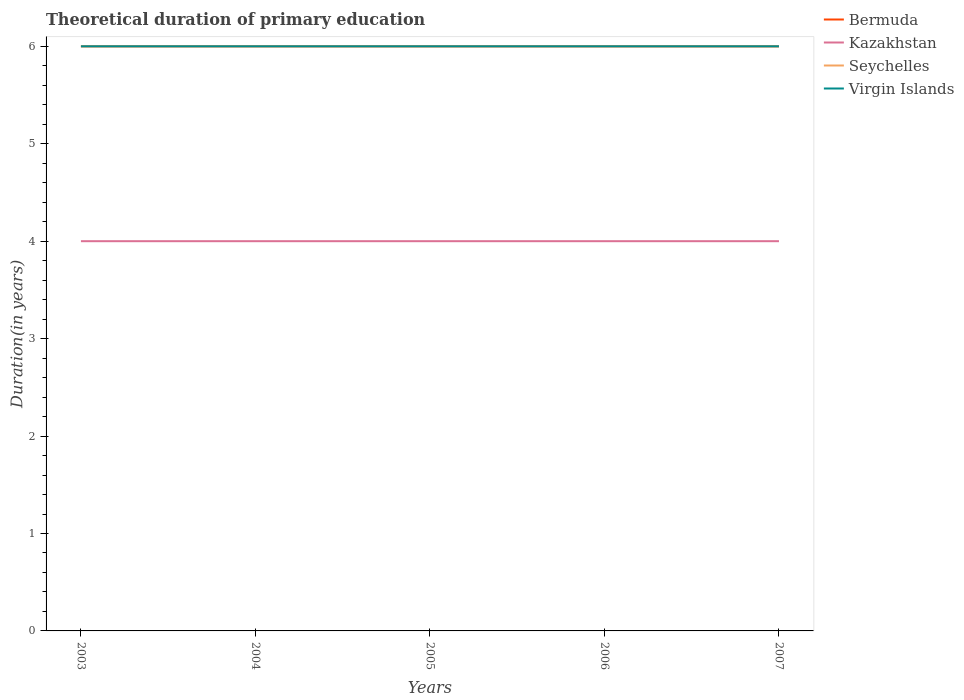What is the total total theoretical duration of primary education in Bermuda in the graph?
Offer a very short reply. 0. Is the total theoretical duration of primary education in Seychelles strictly greater than the total theoretical duration of primary education in Bermuda over the years?
Make the answer very short. No. How many lines are there?
Provide a short and direct response. 4. How many years are there in the graph?
Ensure brevity in your answer.  5. What is the difference between two consecutive major ticks on the Y-axis?
Your answer should be very brief. 1. Does the graph contain grids?
Offer a very short reply. No. How many legend labels are there?
Your answer should be compact. 4. What is the title of the graph?
Keep it short and to the point. Theoretical duration of primary education. Does "Namibia" appear as one of the legend labels in the graph?
Make the answer very short. No. What is the label or title of the X-axis?
Your answer should be very brief. Years. What is the label or title of the Y-axis?
Provide a short and direct response. Duration(in years). What is the Duration(in years) of Seychelles in 2003?
Your answer should be very brief. 6. What is the Duration(in years) in Virgin Islands in 2003?
Offer a terse response. 6. What is the Duration(in years) in Bermuda in 2004?
Your answer should be compact. 6. What is the Duration(in years) in Kazakhstan in 2004?
Ensure brevity in your answer.  4. What is the Duration(in years) in Kazakhstan in 2005?
Ensure brevity in your answer.  4. What is the Duration(in years) of Seychelles in 2006?
Offer a very short reply. 6. What is the Duration(in years) in Kazakhstan in 2007?
Keep it short and to the point. 4. What is the Duration(in years) in Seychelles in 2007?
Your answer should be compact. 6. What is the Duration(in years) of Virgin Islands in 2007?
Offer a terse response. 6. Across all years, what is the maximum Duration(in years) in Kazakhstan?
Offer a terse response. 4. Across all years, what is the maximum Duration(in years) in Seychelles?
Give a very brief answer. 6. Across all years, what is the minimum Duration(in years) of Bermuda?
Keep it short and to the point. 6. What is the total Duration(in years) of Kazakhstan in the graph?
Keep it short and to the point. 20. What is the total Duration(in years) in Virgin Islands in the graph?
Your answer should be compact. 30. What is the difference between the Duration(in years) of Bermuda in 2003 and that in 2004?
Your answer should be compact. 0. What is the difference between the Duration(in years) of Kazakhstan in 2003 and that in 2004?
Provide a succinct answer. 0. What is the difference between the Duration(in years) in Virgin Islands in 2003 and that in 2004?
Provide a succinct answer. 0. What is the difference between the Duration(in years) of Kazakhstan in 2003 and that in 2005?
Your answer should be compact. 0. What is the difference between the Duration(in years) of Seychelles in 2003 and that in 2005?
Ensure brevity in your answer.  0. What is the difference between the Duration(in years) of Virgin Islands in 2003 and that in 2005?
Your answer should be very brief. 0. What is the difference between the Duration(in years) of Seychelles in 2003 and that in 2006?
Ensure brevity in your answer.  0. What is the difference between the Duration(in years) in Bermuda in 2003 and that in 2007?
Provide a short and direct response. 0. What is the difference between the Duration(in years) in Bermuda in 2004 and that in 2005?
Keep it short and to the point. 0. What is the difference between the Duration(in years) in Kazakhstan in 2004 and that in 2006?
Ensure brevity in your answer.  0. What is the difference between the Duration(in years) of Seychelles in 2004 and that in 2006?
Provide a succinct answer. 0. What is the difference between the Duration(in years) in Virgin Islands in 2004 and that in 2007?
Make the answer very short. 0. What is the difference between the Duration(in years) in Kazakhstan in 2005 and that in 2006?
Give a very brief answer. 0. What is the difference between the Duration(in years) of Virgin Islands in 2005 and that in 2006?
Your answer should be very brief. 0. What is the difference between the Duration(in years) in Virgin Islands in 2006 and that in 2007?
Offer a very short reply. 0. What is the difference between the Duration(in years) of Bermuda in 2003 and the Duration(in years) of Seychelles in 2004?
Your answer should be very brief. 0. What is the difference between the Duration(in years) of Bermuda in 2003 and the Duration(in years) of Virgin Islands in 2004?
Ensure brevity in your answer.  0. What is the difference between the Duration(in years) of Kazakhstan in 2003 and the Duration(in years) of Seychelles in 2004?
Your answer should be compact. -2. What is the difference between the Duration(in years) in Bermuda in 2003 and the Duration(in years) in Seychelles in 2005?
Provide a short and direct response. 0. What is the difference between the Duration(in years) in Bermuda in 2003 and the Duration(in years) in Kazakhstan in 2006?
Keep it short and to the point. 2. What is the difference between the Duration(in years) in Kazakhstan in 2003 and the Duration(in years) in Seychelles in 2006?
Offer a terse response. -2. What is the difference between the Duration(in years) in Kazakhstan in 2003 and the Duration(in years) in Virgin Islands in 2006?
Provide a succinct answer. -2. What is the difference between the Duration(in years) of Bermuda in 2003 and the Duration(in years) of Virgin Islands in 2007?
Your answer should be compact. 0. What is the difference between the Duration(in years) in Kazakhstan in 2003 and the Duration(in years) in Virgin Islands in 2007?
Provide a short and direct response. -2. What is the difference between the Duration(in years) in Bermuda in 2004 and the Duration(in years) in Virgin Islands in 2005?
Keep it short and to the point. 0. What is the difference between the Duration(in years) of Kazakhstan in 2004 and the Duration(in years) of Seychelles in 2005?
Your answer should be very brief. -2. What is the difference between the Duration(in years) of Kazakhstan in 2004 and the Duration(in years) of Virgin Islands in 2006?
Provide a succinct answer. -2. What is the difference between the Duration(in years) in Bermuda in 2004 and the Duration(in years) in Seychelles in 2007?
Provide a short and direct response. 0. What is the difference between the Duration(in years) in Bermuda in 2005 and the Duration(in years) in Kazakhstan in 2006?
Your response must be concise. 2. What is the difference between the Duration(in years) in Bermuda in 2005 and the Duration(in years) in Seychelles in 2006?
Make the answer very short. 0. What is the difference between the Duration(in years) in Bermuda in 2005 and the Duration(in years) in Virgin Islands in 2006?
Offer a very short reply. 0. What is the difference between the Duration(in years) of Kazakhstan in 2005 and the Duration(in years) of Seychelles in 2006?
Your response must be concise. -2. What is the difference between the Duration(in years) in Bermuda in 2005 and the Duration(in years) in Virgin Islands in 2007?
Make the answer very short. 0. What is the difference between the Duration(in years) in Bermuda in 2006 and the Duration(in years) in Seychelles in 2007?
Your answer should be compact. 0. What is the difference between the Duration(in years) in Kazakhstan in 2006 and the Duration(in years) in Seychelles in 2007?
Make the answer very short. -2. What is the difference between the Duration(in years) in Seychelles in 2006 and the Duration(in years) in Virgin Islands in 2007?
Provide a succinct answer. 0. What is the average Duration(in years) in Kazakhstan per year?
Offer a terse response. 4. What is the average Duration(in years) in Seychelles per year?
Provide a succinct answer. 6. In the year 2003, what is the difference between the Duration(in years) of Bermuda and Duration(in years) of Seychelles?
Your response must be concise. 0. In the year 2003, what is the difference between the Duration(in years) of Bermuda and Duration(in years) of Virgin Islands?
Offer a terse response. 0. In the year 2004, what is the difference between the Duration(in years) of Bermuda and Duration(in years) of Virgin Islands?
Offer a terse response. 0. In the year 2004, what is the difference between the Duration(in years) in Kazakhstan and Duration(in years) in Virgin Islands?
Ensure brevity in your answer.  -2. In the year 2004, what is the difference between the Duration(in years) of Seychelles and Duration(in years) of Virgin Islands?
Provide a succinct answer. 0. In the year 2005, what is the difference between the Duration(in years) in Kazakhstan and Duration(in years) in Seychelles?
Provide a short and direct response. -2. In the year 2005, what is the difference between the Duration(in years) in Kazakhstan and Duration(in years) in Virgin Islands?
Offer a terse response. -2. In the year 2006, what is the difference between the Duration(in years) in Bermuda and Duration(in years) in Kazakhstan?
Make the answer very short. 2. In the year 2006, what is the difference between the Duration(in years) in Bermuda and Duration(in years) in Seychelles?
Your answer should be very brief. 0. In the year 2006, what is the difference between the Duration(in years) of Kazakhstan and Duration(in years) of Seychelles?
Offer a very short reply. -2. In the year 2007, what is the difference between the Duration(in years) in Bermuda and Duration(in years) in Kazakhstan?
Make the answer very short. 2. In the year 2007, what is the difference between the Duration(in years) of Kazakhstan and Duration(in years) of Seychelles?
Your answer should be very brief. -2. In the year 2007, what is the difference between the Duration(in years) in Seychelles and Duration(in years) in Virgin Islands?
Make the answer very short. 0. What is the ratio of the Duration(in years) in Seychelles in 2003 to that in 2004?
Give a very brief answer. 1. What is the ratio of the Duration(in years) in Bermuda in 2003 to that in 2005?
Give a very brief answer. 1. What is the ratio of the Duration(in years) in Seychelles in 2003 to that in 2005?
Offer a very short reply. 1. What is the ratio of the Duration(in years) in Bermuda in 2003 to that in 2006?
Keep it short and to the point. 1. What is the ratio of the Duration(in years) in Kazakhstan in 2003 to that in 2006?
Offer a very short reply. 1. What is the ratio of the Duration(in years) in Virgin Islands in 2003 to that in 2006?
Give a very brief answer. 1. What is the ratio of the Duration(in years) in Kazakhstan in 2003 to that in 2007?
Your answer should be compact. 1. What is the ratio of the Duration(in years) of Seychelles in 2003 to that in 2007?
Your answer should be very brief. 1. What is the ratio of the Duration(in years) in Virgin Islands in 2003 to that in 2007?
Give a very brief answer. 1. What is the ratio of the Duration(in years) of Seychelles in 2004 to that in 2005?
Provide a succinct answer. 1. What is the ratio of the Duration(in years) of Virgin Islands in 2004 to that in 2005?
Keep it short and to the point. 1. What is the ratio of the Duration(in years) of Bermuda in 2004 to that in 2006?
Keep it short and to the point. 1. What is the ratio of the Duration(in years) in Kazakhstan in 2004 to that in 2006?
Offer a terse response. 1. What is the ratio of the Duration(in years) of Virgin Islands in 2004 to that in 2006?
Your answer should be compact. 1. What is the ratio of the Duration(in years) in Bermuda in 2004 to that in 2007?
Make the answer very short. 1. What is the ratio of the Duration(in years) of Kazakhstan in 2004 to that in 2007?
Offer a terse response. 1. What is the ratio of the Duration(in years) in Bermuda in 2005 to that in 2006?
Your answer should be very brief. 1. What is the ratio of the Duration(in years) in Kazakhstan in 2005 to that in 2006?
Keep it short and to the point. 1. What is the ratio of the Duration(in years) of Seychelles in 2005 to that in 2006?
Keep it short and to the point. 1. What is the ratio of the Duration(in years) of Bermuda in 2005 to that in 2007?
Give a very brief answer. 1. What is the ratio of the Duration(in years) of Virgin Islands in 2005 to that in 2007?
Offer a very short reply. 1. What is the ratio of the Duration(in years) in Bermuda in 2006 to that in 2007?
Your answer should be compact. 1. What is the ratio of the Duration(in years) of Seychelles in 2006 to that in 2007?
Make the answer very short. 1. What is the ratio of the Duration(in years) in Virgin Islands in 2006 to that in 2007?
Your answer should be very brief. 1. What is the difference between the highest and the lowest Duration(in years) in Kazakhstan?
Provide a short and direct response. 0. What is the difference between the highest and the lowest Duration(in years) in Virgin Islands?
Ensure brevity in your answer.  0. 